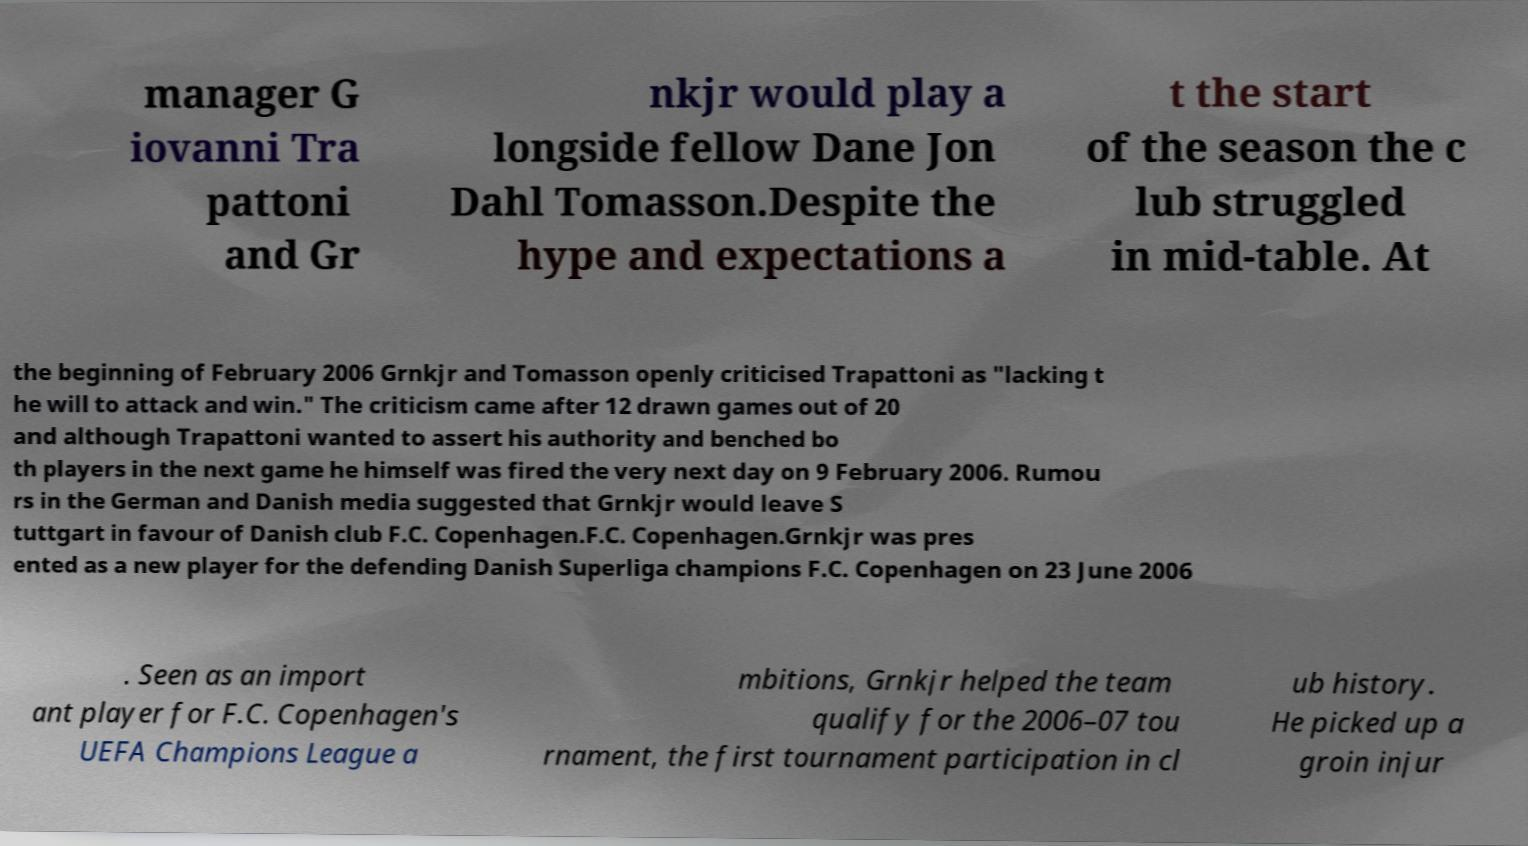Please identify and transcribe the text found in this image. manager G iovanni Tra pattoni and Gr nkjr would play a longside fellow Dane Jon Dahl Tomasson.Despite the hype and expectations a t the start of the season the c lub struggled in mid-table. At the beginning of February 2006 Grnkjr and Tomasson openly criticised Trapattoni as "lacking t he will to attack and win." The criticism came after 12 drawn games out of 20 and although Trapattoni wanted to assert his authority and benched bo th players in the next game he himself was fired the very next day on 9 February 2006. Rumou rs in the German and Danish media suggested that Grnkjr would leave S tuttgart in favour of Danish club F.C. Copenhagen.F.C. Copenhagen.Grnkjr was pres ented as a new player for the defending Danish Superliga champions F.C. Copenhagen on 23 June 2006 . Seen as an import ant player for F.C. Copenhagen's UEFA Champions League a mbitions, Grnkjr helped the team qualify for the 2006–07 tou rnament, the first tournament participation in cl ub history. He picked up a groin injur 